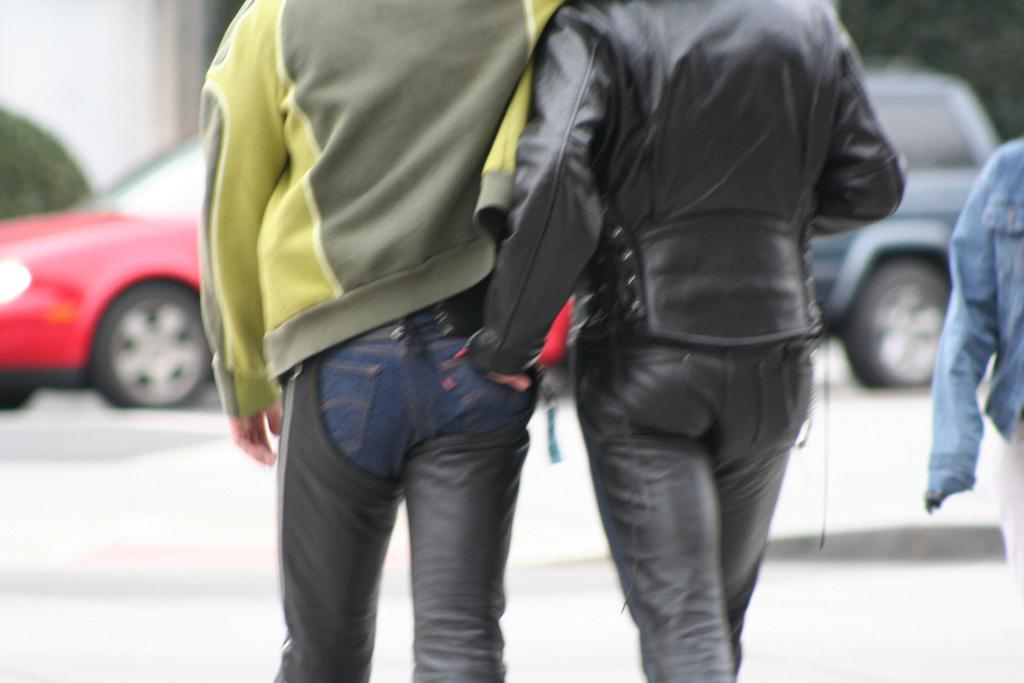How many people are in the image? There are persons in the image, but the exact number is not specified. What can be seen on the road in the image? There are motor vehicles on the road in the image. What type of natural elements are visible in the background of the image? There are trees in the background of the image. What type of man-made structures can be seen in the background of the image? There are walls in the background of the image. What type of beef is being served at the restaurant in the image? There is no restaurant or beef present in the image. How do the brothers in the image compare to each other? There is no mention of brothers or a comparison in the image. 